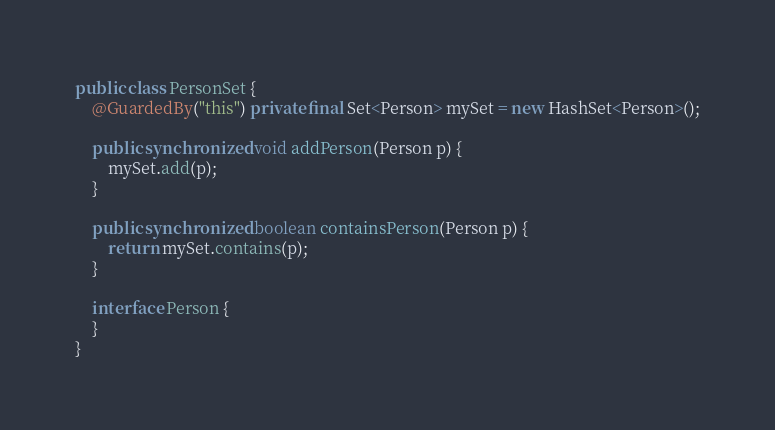<code> <loc_0><loc_0><loc_500><loc_500><_Java_>public class PersonSet {
    @GuardedBy("this") private final Set<Person> mySet = new HashSet<Person>();

    public synchronized void addPerson(Person p) {
        mySet.add(p);
    }

    public synchronized boolean containsPerson(Person p) {
        return mySet.contains(p);
    }

    interface Person {
    }
}
</code> 